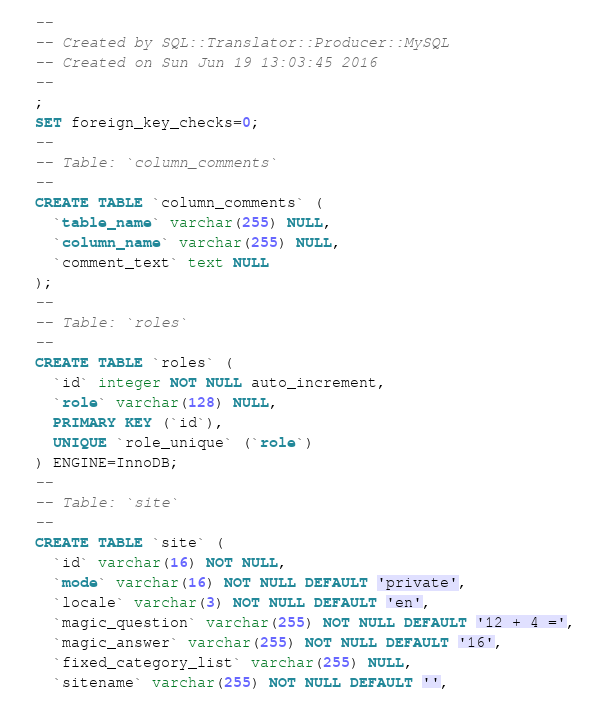Convert code to text. <code><loc_0><loc_0><loc_500><loc_500><_SQL_>-- 
-- Created by SQL::Translator::Producer::MySQL
-- Created on Sun Jun 19 13:03:45 2016
-- 
;
SET foreign_key_checks=0;
--
-- Table: `column_comments`
--
CREATE TABLE `column_comments` (
  `table_name` varchar(255) NULL,
  `column_name` varchar(255) NULL,
  `comment_text` text NULL
);
--
-- Table: `roles`
--
CREATE TABLE `roles` (
  `id` integer NOT NULL auto_increment,
  `role` varchar(128) NULL,
  PRIMARY KEY (`id`),
  UNIQUE `role_unique` (`role`)
) ENGINE=InnoDB;
--
-- Table: `site`
--
CREATE TABLE `site` (
  `id` varchar(16) NOT NULL,
  `mode` varchar(16) NOT NULL DEFAULT 'private',
  `locale` varchar(3) NOT NULL DEFAULT 'en',
  `magic_question` varchar(255) NOT NULL DEFAULT '12 + 4 =',
  `magic_answer` varchar(255) NOT NULL DEFAULT '16',
  `fixed_category_list` varchar(255) NULL,
  `sitename` varchar(255) NOT NULL DEFAULT '',</code> 